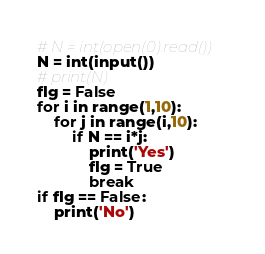Convert code to text. <code><loc_0><loc_0><loc_500><loc_500><_Python_># N = int(open(0).read())
N = int(input())
# print(N)
flg = False
for i in range(1,10):
    for j in range(i,10):
        if N == i*j:
            print('Yes')
            flg = True
            break
if flg == False:
    print('No')</code> 